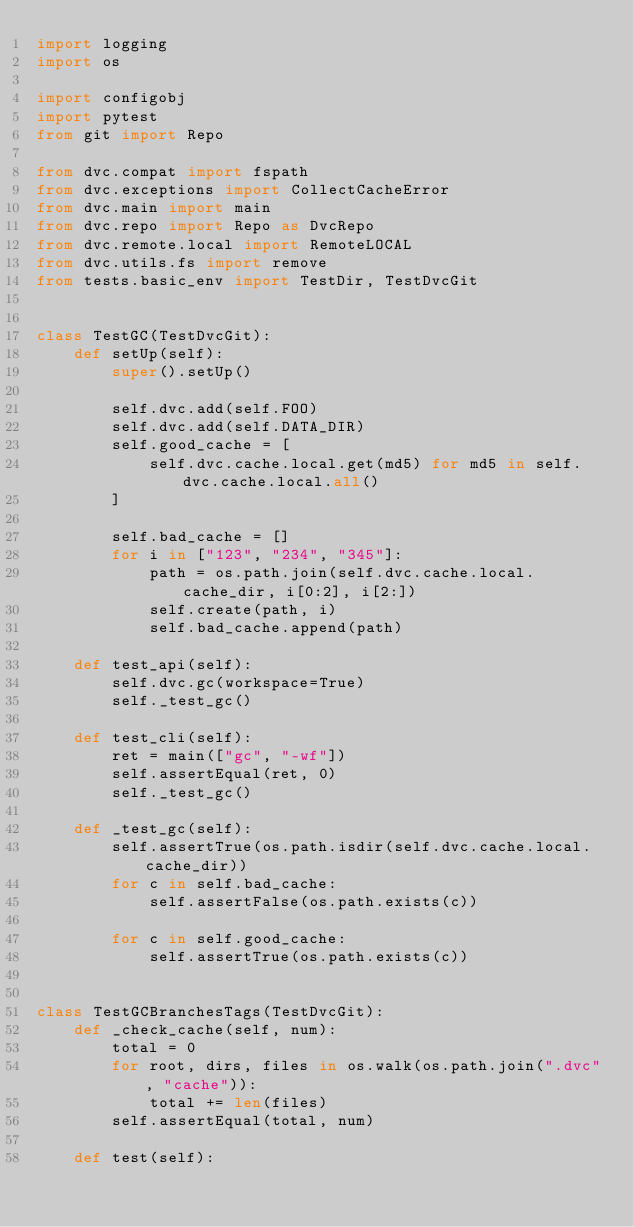<code> <loc_0><loc_0><loc_500><loc_500><_Python_>import logging
import os

import configobj
import pytest
from git import Repo

from dvc.compat import fspath
from dvc.exceptions import CollectCacheError
from dvc.main import main
from dvc.repo import Repo as DvcRepo
from dvc.remote.local import RemoteLOCAL
from dvc.utils.fs import remove
from tests.basic_env import TestDir, TestDvcGit


class TestGC(TestDvcGit):
    def setUp(self):
        super().setUp()

        self.dvc.add(self.FOO)
        self.dvc.add(self.DATA_DIR)
        self.good_cache = [
            self.dvc.cache.local.get(md5) for md5 in self.dvc.cache.local.all()
        ]

        self.bad_cache = []
        for i in ["123", "234", "345"]:
            path = os.path.join(self.dvc.cache.local.cache_dir, i[0:2], i[2:])
            self.create(path, i)
            self.bad_cache.append(path)

    def test_api(self):
        self.dvc.gc(workspace=True)
        self._test_gc()

    def test_cli(self):
        ret = main(["gc", "-wf"])
        self.assertEqual(ret, 0)
        self._test_gc()

    def _test_gc(self):
        self.assertTrue(os.path.isdir(self.dvc.cache.local.cache_dir))
        for c in self.bad_cache:
            self.assertFalse(os.path.exists(c))

        for c in self.good_cache:
            self.assertTrue(os.path.exists(c))


class TestGCBranchesTags(TestDvcGit):
    def _check_cache(self, num):
        total = 0
        for root, dirs, files in os.walk(os.path.join(".dvc", "cache")):
            total += len(files)
        self.assertEqual(total, num)

    def test(self):</code> 